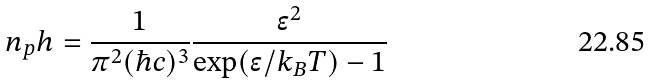Convert formula to latex. <formula><loc_0><loc_0><loc_500><loc_500>n _ { p } h = \frac { 1 } { \pi ^ { 2 } ( \hbar { c } ) ^ { 3 } } \frac { \epsilon ^ { 2 } } { \exp ( \epsilon / k _ { B } T ) - 1 }</formula> 